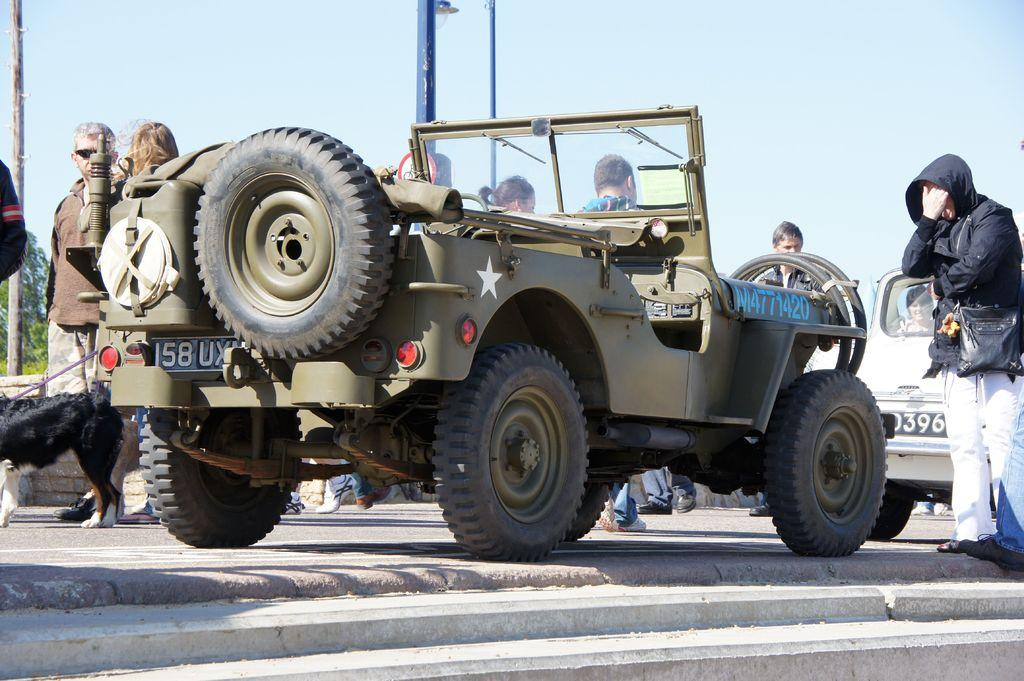What type of vehicle is in the image? There is a brown color Jeep in the image. Where is the Jeep parked? The Jeep is parked on the front side of the footpath. What is happening in the image involving people? There are two people walking in the image. How are the people positioned in relation to the Jeep? The people are walking behind the Jeep. Are there any animals present in the image? Yes, the people are accompanied by a black color dog. What division of the police force is responsible for patrolling the area in the image? There is no indication of any police presence or division in the image. 